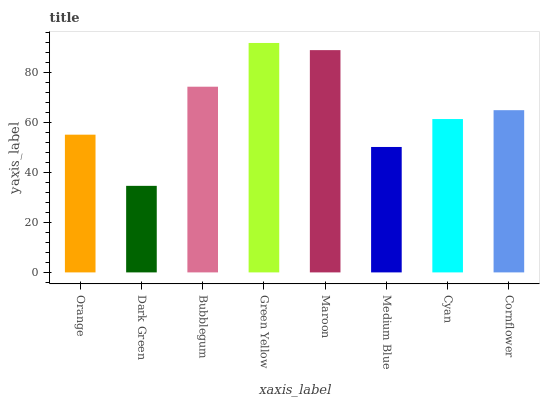Is Dark Green the minimum?
Answer yes or no. Yes. Is Green Yellow the maximum?
Answer yes or no. Yes. Is Bubblegum the minimum?
Answer yes or no. No. Is Bubblegum the maximum?
Answer yes or no. No. Is Bubblegum greater than Dark Green?
Answer yes or no. Yes. Is Dark Green less than Bubblegum?
Answer yes or no. Yes. Is Dark Green greater than Bubblegum?
Answer yes or no. No. Is Bubblegum less than Dark Green?
Answer yes or no. No. Is Cornflower the high median?
Answer yes or no. Yes. Is Cyan the low median?
Answer yes or no. Yes. Is Bubblegum the high median?
Answer yes or no. No. Is Cornflower the low median?
Answer yes or no. No. 